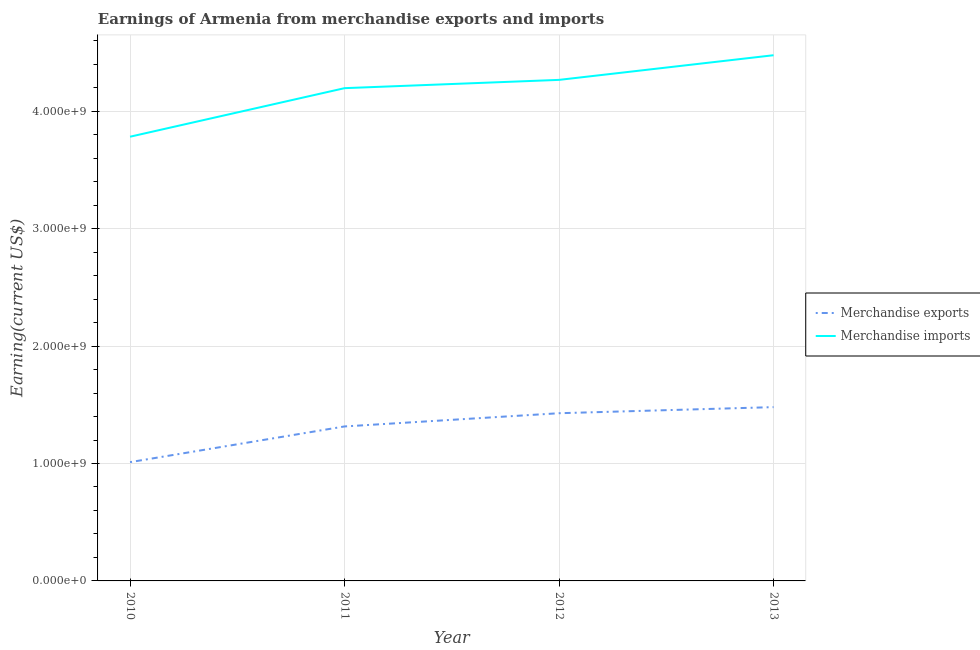How many different coloured lines are there?
Your response must be concise. 2. Does the line corresponding to earnings from merchandise exports intersect with the line corresponding to earnings from merchandise imports?
Your answer should be very brief. No. What is the earnings from merchandise exports in 2010?
Keep it short and to the point. 1.01e+09. Across all years, what is the maximum earnings from merchandise imports?
Keep it short and to the point. 4.48e+09. Across all years, what is the minimum earnings from merchandise imports?
Ensure brevity in your answer.  3.78e+09. What is the total earnings from merchandise imports in the graph?
Your answer should be compact. 1.67e+1. What is the difference between the earnings from merchandise imports in 2011 and that in 2012?
Give a very brief answer. -7.05e+07. What is the difference between the earnings from merchandise imports in 2012 and the earnings from merchandise exports in 2010?
Make the answer very short. 3.26e+09. What is the average earnings from merchandise imports per year?
Offer a very short reply. 4.18e+09. In the year 2011, what is the difference between the earnings from merchandise exports and earnings from merchandise imports?
Offer a terse response. -2.88e+09. In how many years, is the earnings from merchandise exports greater than 4000000000 US$?
Your answer should be very brief. 0. What is the ratio of the earnings from merchandise imports in 2010 to that in 2012?
Offer a very short reply. 0.89. What is the difference between the highest and the second highest earnings from merchandise imports?
Make the answer very short. 2.10e+08. What is the difference between the highest and the lowest earnings from merchandise imports?
Your response must be concise. 6.94e+08. Is the sum of the earnings from merchandise imports in 2011 and 2012 greater than the maximum earnings from merchandise exports across all years?
Give a very brief answer. Yes. Is the earnings from merchandise imports strictly greater than the earnings from merchandise exports over the years?
Provide a succinct answer. Yes. Is the earnings from merchandise exports strictly less than the earnings from merchandise imports over the years?
Offer a very short reply. Yes. How many years are there in the graph?
Provide a succinct answer. 4. Are the values on the major ticks of Y-axis written in scientific E-notation?
Ensure brevity in your answer.  Yes. Does the graph contain any zero values?
Provide a short and direct response. No. Where does the legend appear in the graph?
Provide a short and direct response. Center right. How many legend labels are there?
Your response must be concise. 2. How are the legend labels stacked?
Your answer should be compact. Vertical. What is the title of the graph?
Keep it short and to the point. Earnings of Armenia from merchandise exports and imports. Does "Drinking water services" appear as one of the legend labels in the graph?
Give a very brief answer. No. What is the label or title of the Y-axis?
Your answer should be very brief. Earning(current US$). What is the Earning(current US$) in Merchandise exports in 2010?
Give a very brief answer. 1.01e+09. What is the Earning(current US$) of Merchandise imports in 2010?
Make the answer very short. 3.78e+09. What is the Earning(current US$) in Merchandise exports in 2011?
Provide a succinct answer. 1.32e+09. What is the Earning(current US$) of Merchandise imports in 2011?
Offer a terse response. 4.20e+09. What is the Earning(current US$) of Merchandise exports in 2012?
Provide a succinct answer. 1.43e+09. What is the Earning(current US$) in Merchandise imports in 2012?
Provide a short and direct response. 4.27e+09. What is the Earning(current US$) of Merchandise exports in 2013?
Provide a succinct answer. 1.48e+09. What is the Earning(current US$) of Merchandise imports in 2013?
Provide a succinct answer. 4.48e+09. Across all years, what is the maximum Earning(current US$) in Merchandise exports?
Your response must be concise. 1.48e+09. Across all years, what is the maximum Earning(current US$) of Merchandise imports?
Give a very brief answer. 4.48e+09. Across all years, what is the minimum Earning(current US$) of Merchandise exports?
Provide a succinct answer. 1.01e+09. Across all years, what is the minimum Earning(current US$) of Merchandise imports?
Your answer should be compact. 3.78e+09. What is the total Earning(current US$) of Merchandise exports in the graph?
Offer a very short reply. 5.24e+09. What is the total Earning(current US$) in Merchandise imports in the graph?
Offer a very short reply. 1.67e+1. What is the difference between the Earning(current US$) in Merchandise exports in 2010 and that in 2011?
Keep it short and to the point. -3.04e+08. What is the difference between the Earning(current US$) of Merchandise imports in 2010 and that in 2011?
Provide a short and direct response. -4.13e+08. What is the difference between the Earning(current US$) of Merchandise exports in 2010 and that in 2012?
Your answer should be compact. -4.17e+08. What is the difference between the Earning(current US$) in Merchandise imports in 2010 and that in 2012?
Provide a succinct answer. -4.84e+08. What is the difference between the Earning(current US$) in Merchandise exports in 2010 and that in 2013?
Ensure brevity in your answer.  -4.69e+08. What is the difference between the Earning(current US$) of Merchandise imports in 2010 and that in 2013?
Your answer should be compact. -6.94e+08. What is the difference between the Earning(current US$) in Merchandise exports in 2011 and that in 2012?
Give a very brief answer. -1.13e+08. What is the difference between the Earning(current US$) in Merchandise imports in 2011 and that in 2012?
Offer a very short reply. -7.05e+07. What is the difference between the Earning(current US$) of Merchandise exports in 2011 and that in 2013?
Provide a succinct answer. -1.64e+08. What is the difference between the Earning(current US$) in Merchandise imports in 2011 and that in 2013?
Your answer should be very brief. -2.80e+08. What is the difference between the Earning(current US$) in Merchandise exports in 2012 and that in 2013?
Ensure brevity in your answer.  -5.19e+07. What is the difference between the Earning(current US$) of Merchandise imports in 2012 and that in 2013?
Offer a terse response. -2.10e+08. What is the difference between the Earning(current US$) of Merchandise exports in 2010 and the Earning(current US$) of Merchandise imports in 2011?
Make the answer very short. -3.18e+09. What is the difference between the Earning(current US$) of Merchandise exports in 2010 and the Earning(current US$) of Merchandise imports in 2012?
Make the answer very short. -3.26e+09. What is the difference between the Earning(current US$) in Merchandise exports in 2010 and the Earning(current US$) in Merchandise imports in 2013?
Your answer should be very brief. -3.47e+09. What is the difference between the Earning(current US$) in Merchandise exports in 2011 and the Earning(current US$) in Merchandise imports in 2012?
Your answer should be very brief. -2.95e+09. What is the difference between the Earning(current US$) of Merchandise exports in 2011 and the Earning(current US$) of Merchandise imports in 2013?
Provide a short and direct response. -3.16e+09. What is the difference between the Earning(current US$) of Merchandise exports in 2012 and the Earning(current US$) of Merchandise imports in 2013?
Provide a succinct answer. -3.05e+09. What is the average Earning(current US$) in Merchandise exports per year?
Give a very brief answer. 1.31e+09. What is the average Earning(current US$) in Merchandise imports per year?
Make the answer very short. 4.18e+09. In the year 2010, what is the difference between the Earning(current US$) in Merchandise exports and Earning(current US$) in Merchandise imports?
Provide a succinct answer. -2.77e+09. In the year 2011, what is the difference between the Earning(current US$) in Merchandise exports and Earning(current US$) in Merchandise imports?
Provide a succinct answer. -2.88e+09. In the year 2012, what is the difference between the Earning(current US$) in Merchandise exports and Earning(current US$) in Merchandise imports?
Ensure brevity in your answer.  -2.84e+09. In the year 2013, what is the difference between the Earning(current US$) in Merchandise exports and Earning(current US$) in Merchandise imports?
Offer a terse response. -3.00e+09. What is the ratio of the Earning(current US$) in Merchandise exports in 2010 to that in 2011?
Provide a short and direct response. 0.77. What is the ratio of the Earning(current US$) in Merchandise imports in 2010 to that in 2011?
Ensure brevity in your answer.  0.9. What is the ratio of the Earning(current US$) of Merchandise exports in 2010 to that in 2012?
Provide a short and direct response. 0.71. What is the ratio of the Earning(current US$) in Merchandise imports in 2010 to that in 2012?
Ensure brevity in your answer.  0.89. What is the ratio of the Earning(current US$) in Merchandise exports in 2010 to that in 2013?
Give a very brief answer. 0.68. What is the ratio of the Earning(current US$) of Merchandise imports in 2010 to that in 2013?
Your answer should be very brief. 0.84. What is the ratio of the Earning(current US$) of Merchandise exports in 2011 to that in 2012?
Provide a succinct answer. 0.92. What is the ratio of the Earning(current US$) in Merchandise imports in 2011 to that in 2012?
Your answer should be very brief. 0.98. What is the ratio of the Earning(current US$) of Merchandise imports in 2011 to that in 2013?
Ensure brevity in your answer.  0.94. What is the ratio of the Earning(current US$) in Merchandise exports in 2012 to that in 2013?
Make the answer very short. 0.96. What is the ratio of the Earning(current US$) of Merchandise imports in 2012 to that in 2013?
Ensure brevity in your answer.  0.95. What is the difference between the highest and the second highest Earning(current US$) of Merchandise exports?
Give a very brief answer. 5.19e+07. What is the difference between the highest and the second highest Earning(current US$) of Merchandise imports?
Offer a very short reply. 2.10e+08. What is the difference between the highest and the lowest Earning(current US$) in Merchandise exports?
Make the answer very short. 4.69e+08. What is the difference between the highest and the lowest Earning(current US$) in Merchandise imports?
Keep it short and to the point. 6.94e+08. 